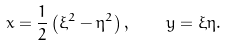Convert formula to latex. <formula><loc_0><loc_0><loc_500><loc_500>x = \frac { 1 } { 2 } \left ( \xi ^ { 2 } - \eta ^ { 2 } \right ) , \quad y = \xi \eta .</formula> 